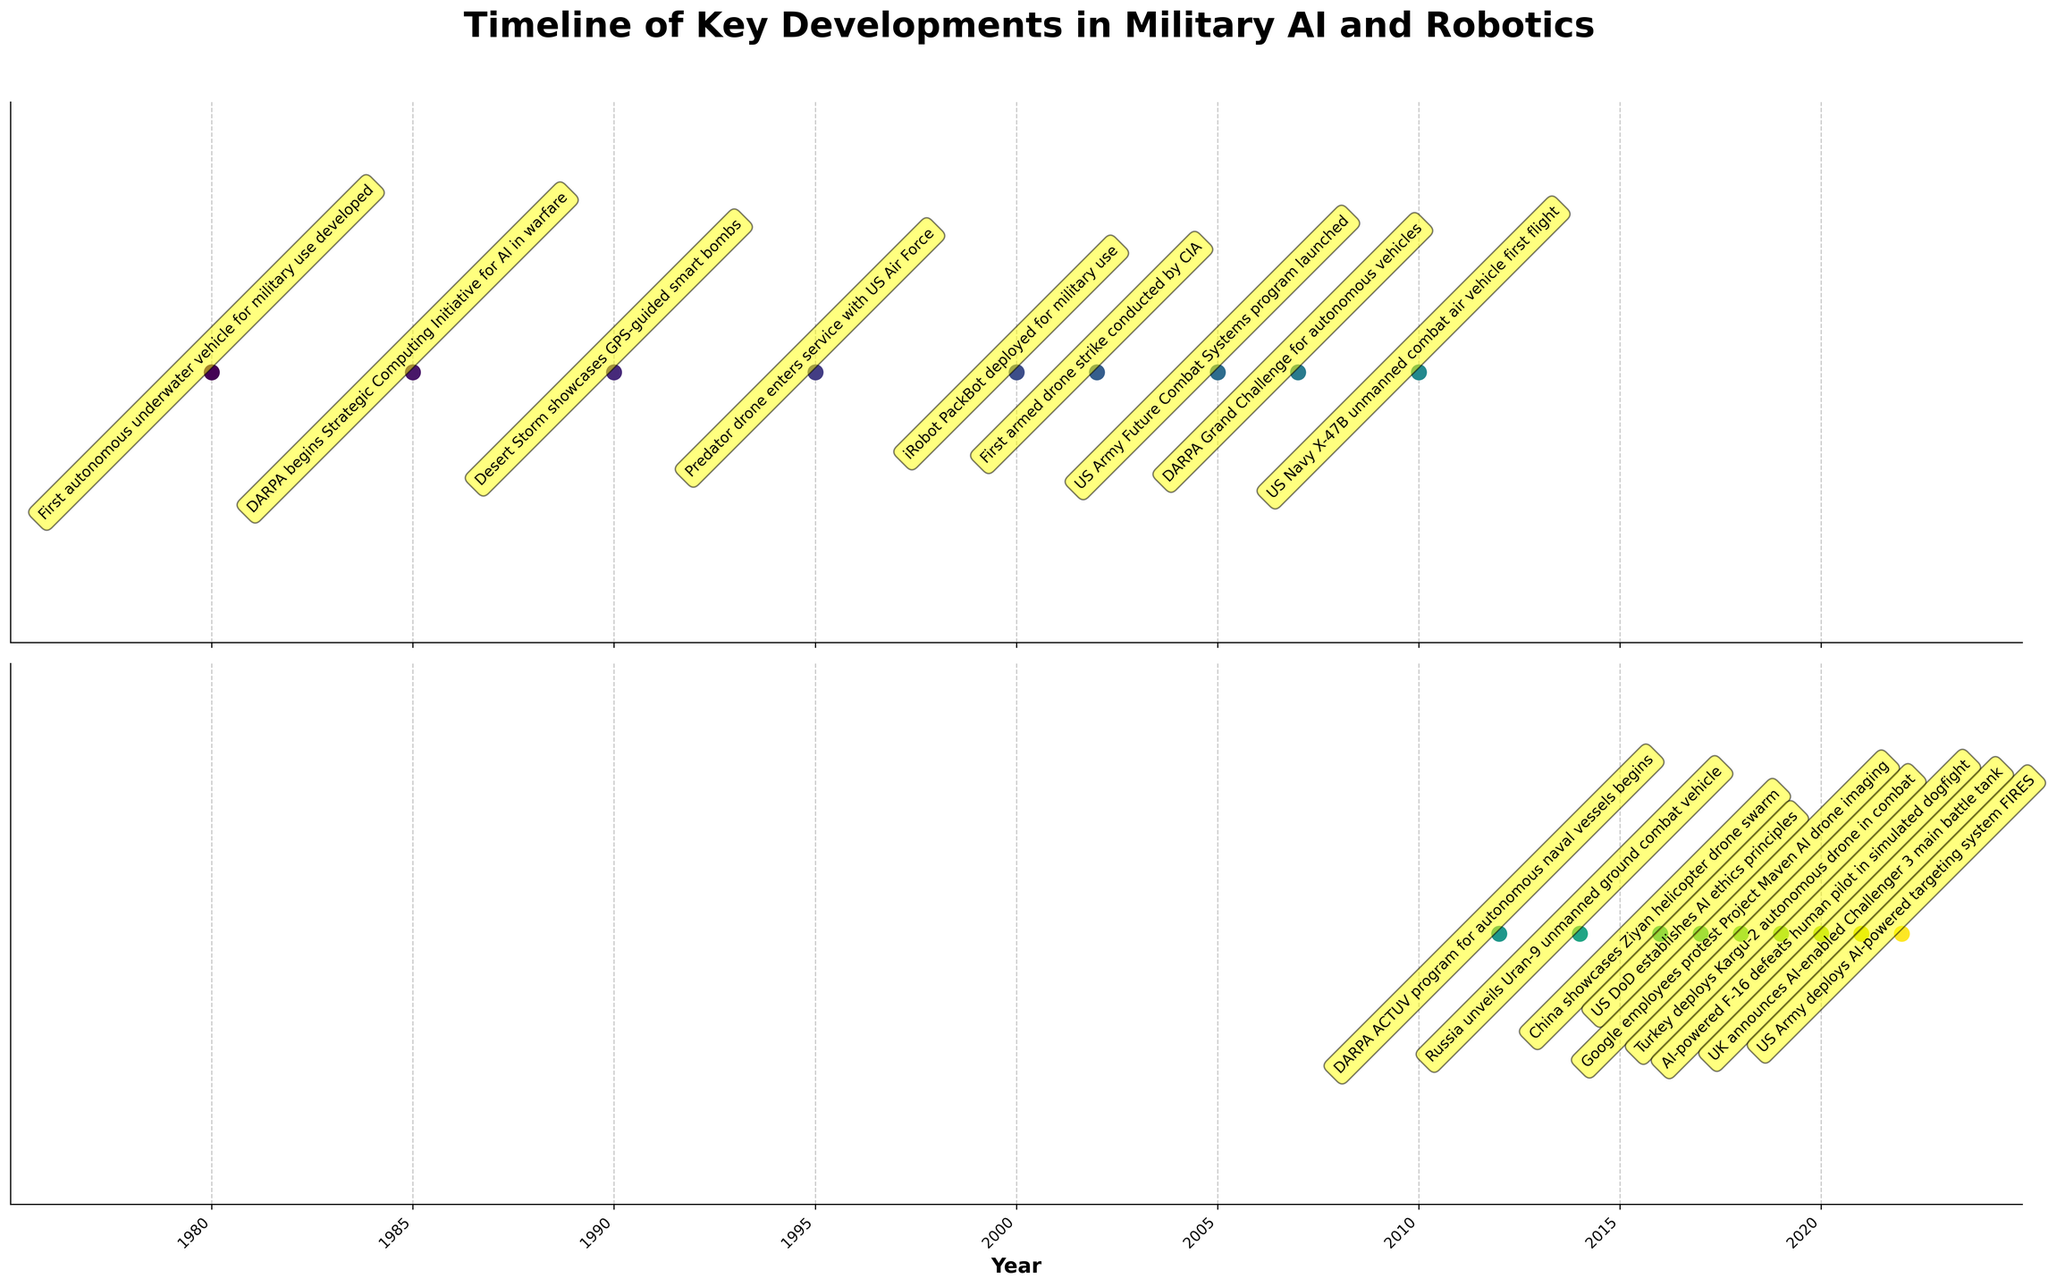What year was the first armed drone strike conducted? According to the figure, the first armed drone strike is marked in the year 2002.
Answer: 2002 Which event occurred earlier, the DARPA Grand Challenge for autonomous vehicles or the deployment of the Kargu-2 autonomous drone in combat? The figure shows the DARPA Grand Challenge for autonomous vehicles in 2007 and the deployment of the Kargu-2 autonomous drone in 2019. Since 2007 is earlier than 2019, the DARPA Grand Challenge occurred first.
Answer: DARPA Grand Challenge for autonomous vehicles How many years passed between the first autonomous underwater vehicle's development and the X-47B unmanned combat air vehicle's first flight? The first autonomous underwater vehicle was developed in 1980, and the X-47B's first flight occurred in 2010. Subtracting the years gives us 2010 - 1980 = 30 years.
Answer: 30 years Which two events in the timeline are associated with drones? The figure shows that in 1995, the Predator drone entered service with the US Air Force, and in 2002, the first armed drone strike was conducted by the CIA.
Answer: Predator drone enters service with US Air Force, and first armed drone strike by CIA What event happened in 2018 related to Google? According to the figure, in 2018, Google employees protested Project Maven AI drone imaging.
Answer: Google employees protest Project Maven AI drone imaging What is the time difference between the launch of the US Army Future Combat Systems program and the announcement of the AI-enabled Challenger 3 main battle tank? The figure shows the US Army Future Combat Systems program launched in 2005 and the AI-enabled Challenger 3 main battle tank announced in 2021. The time difference is 2021 - 2005 = 16 years.
Answer: 16 years In which year did DARPA begin the Strategic Computing Initiative for AI in warfare? The figure indicates that DARPA began the Strategic Computing Initiative for AI in warfare in 1985.
Answer: 1985 Which event involving AI in combat occurred first, the deployment of AI-powered F-16 in a simulated dogfight or the deployment of the US Army's AI-powered targeting system FIRES? The figure notes that the AI-powered F-16 defeated a human pilot in 2020, and the US Army deployed the AI-powered targeting system FIRES in 2022. Since 2020 is earlier than 2022, the AI-powered F-16 event occurred first.
Answer: AI-powered F-16 in a simulated dogfight 